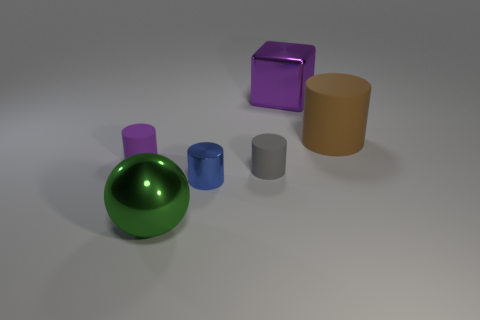Subtract all gray cylinders. How many cylinders are left? 3 Subtract 1 cylinders. How many cylinders are left? 3 Add 2 balls. How many objects exist? 8 Subtract all green cylinders. Subtract all blue spheres. How many cylinders are left? 4 Subtract all cubes. How many objects are left? 5 Add 2 brown rubber things. How many brown rubber things are left? 3 Add 6 tiny rubber cylinders. How many tiny rubber cylinders exist? 8 Subtract 0 red cylinders. How many objects are left? 6 Subtract all big brown objects. Subtract all tiny cylinders. How many objects are left? 2 